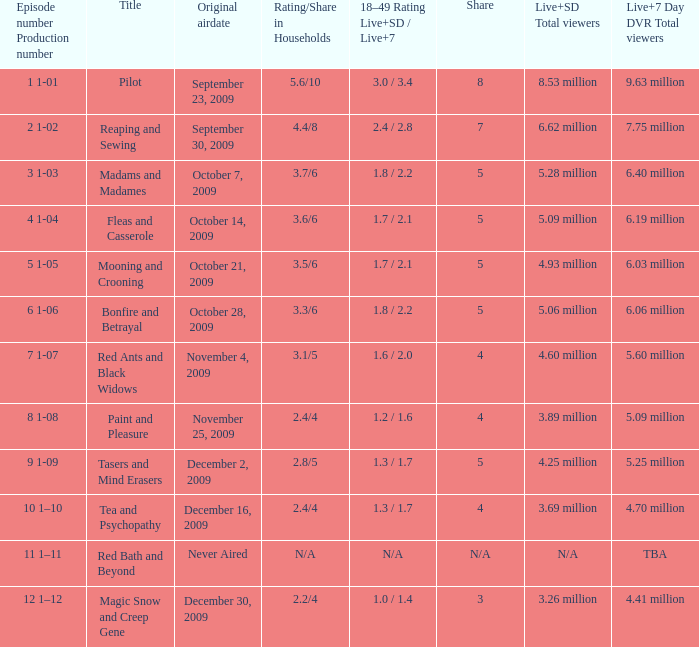What was the combined live and sd viewership count for the episode that had a share of 8? 9.63 million. 